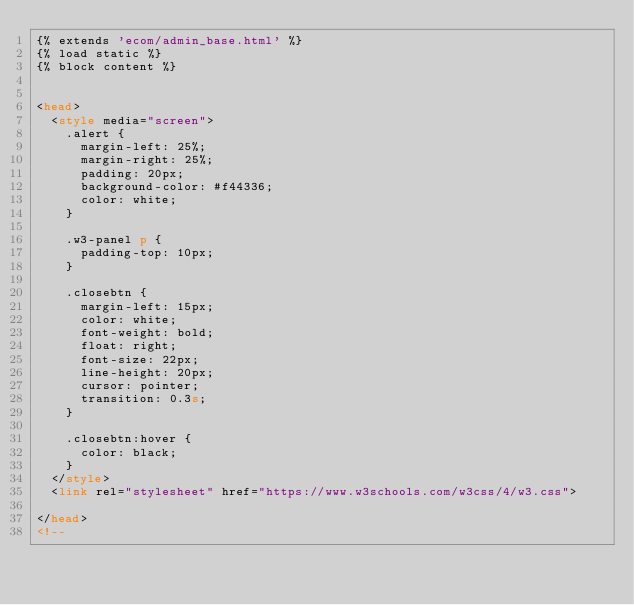Convert code to text. <code><loc_0><loc_0><loc_500><loc_500><_HTML_>{% extends 'ecom/admin_base.html' %}
{% load static %}
{% block content %}


<head>
  <style media="screen">
    .alert {
      margin-left: 25%;
      margin-right: 25%;
      padding: 20px;
      background-color: #f44336;
      color: white;
    }

    .w3-panel p {
      padding-top: 10px;
    }

    .closebtn {
      margin-left: 15px;
      color: white;
      font-weight: bold;
      float: right;
      font-size: 22px;
      line-height: 20px;
      cursor: pointer;
      transition: 0.3s;
    }

    .closebtn:hover {
      color: black;
    }
  </style>
  <link rel="stylesheet" href="https://www.w3schools.com/w3css/4/w3.css">

</head>
<!--</code> 